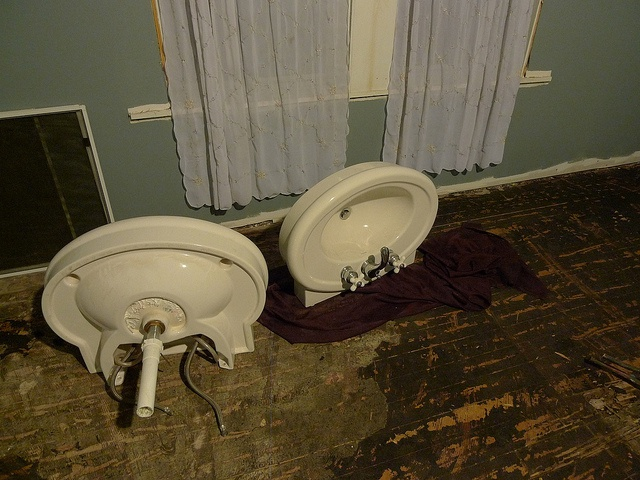Describe the objects in this image and their specific colors. I can see a sink in darkgreen, tan, olive, and black tones in this image. 